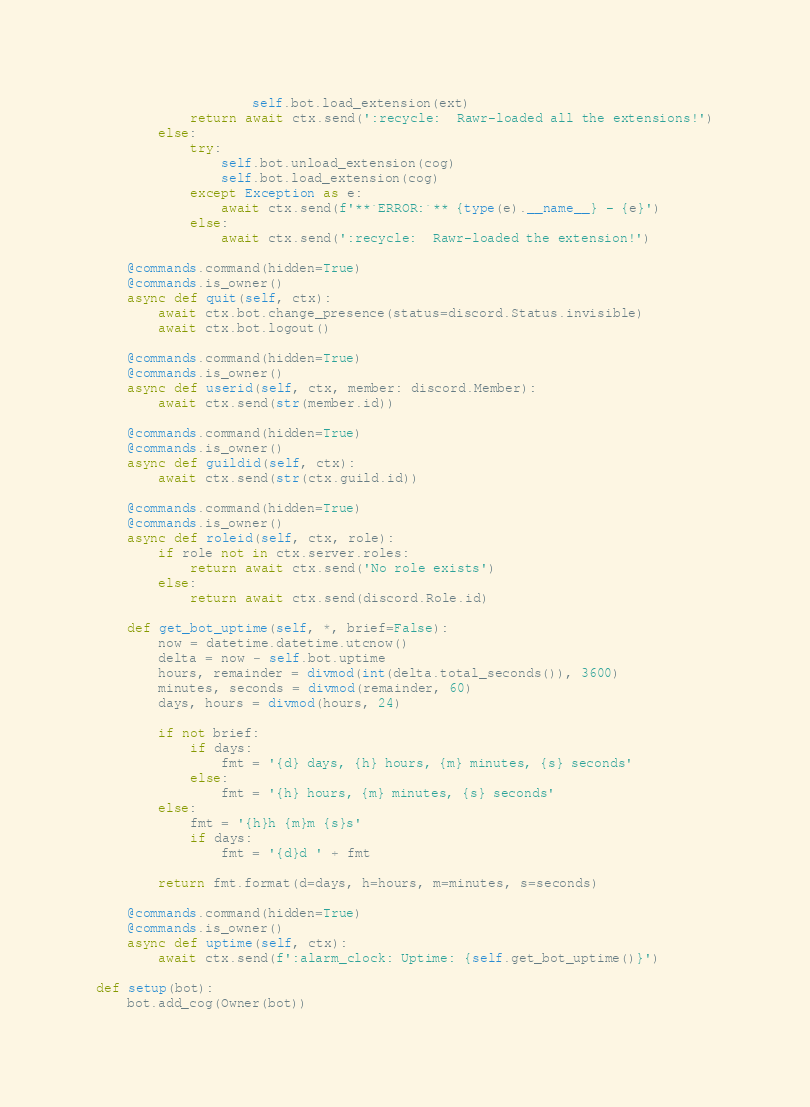<code> <loc_0><loc_0><loc_500><loc_500><_Python_>                    self.bot.load_extension(ext)
            return await ctx.send(':recycle:  Rawr-loaded all the extensions!')
        else:
            try:
                self.bot.unload_extension(cog)
                self.bot.load_extension(cog)
            except Exception as e:
                await ctx.send(f'**`ERROR:`** {type(e).__name__} - {e}')
            else:
                await ctx.send(':recycle:  Rawr-loaded the extension!')

    @commands.command(hidden=True)
    @commands.is_owner()
    async def quit(self, ctx):
        await ctx.bot.change_presence(status=discord.Status.invisible)
        await ctx.bot.logout()

    @commands.command(hidden=True)
    @commands.is_owner()
    async def userid(self, ctx, member: discord.Member):
        await ctx.send(str(member.id))

    @commands.command(hidden=True)
    @commands.is_owner()
    async def guildid(self, ctx):
        await ctx.send(str(ctx.guild.id))

    @commands.command(hidden=True)
    @commands.is_owner()
    async def roleid(self, ctx, role):
        if role not in ctx.server.roles:
            return await ctx.send('No role exists')
        else:
            return await ctx.send(discord.Role.id)

    def get_bot_uptime(self, *, brief=False):
        now = datetime.datetime.utcnow()
        delta = now - self.bot.uptime
        hours, remainder = divmod(int(delta.total_seconds()), 3600)
        minutes, seconds = divmod(remainder, 60)
        days, hours = divmod(hours, 24)

        if not brief:
            if days:
                fmt = '{d} days, {h} hours, {m} minutes, {s} seconds'
            else:
                fmt = '{h} hours, {m} minutes, {s} seconds'
        else:
            fmt = '{h}h {m}m {s}s'
            if days:
                fmt = '{d}d ' + fmt

        return fmt.format(d=days, h=hours, m=minutes, s=seconds)

    @commands.command(hidden=True)
    @commands.is_owner()
    async def uptime(self, ctx):
        await ctx.send(f':alarm_clock: Uptime: {self.get_bot_uptime()}')

def setup(bot):
    bot.add_cog(Owner(bot))
</code> 